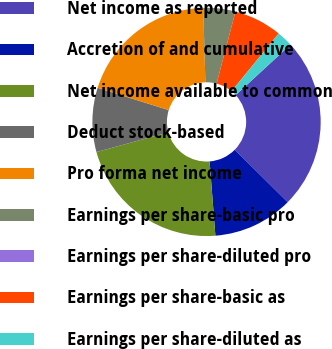Convert chart. <chart><loc_0><loc_0><loc_500><loc_500><pie_chart><fcel>Net income as reported<fcel>Accretion of and cumulative<fcel>Net income available to common<fcel>Deduct stock-based<fcel>Pro forma net income<fcel>Earnings per share-basic pro<fcel>Earnings per share-diluted pro<fcel>Earnings per share-basic as<fcel>Earnings per share-diluted as<nl><fcel>24.25%<fcel>11.35%<fcel>21.98%<fcel>9.08%<fcel>19.71%<fcel>4.54%<fcel>0.0%<fcel>6.81%<fcel>2.27%<nl></chart> 